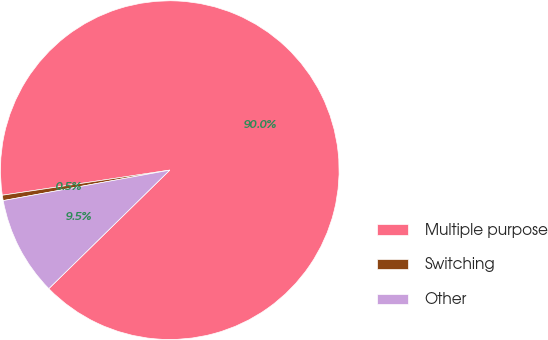<chart> <loc_0><loc_0><loc_500><loc_500><pie_chart><fcel>Multiple purpose<fcel>Switching<fcel>Other<nl><fcel>90.04%<fcel>0.51%<fcel>9.46%<nl></chart> 